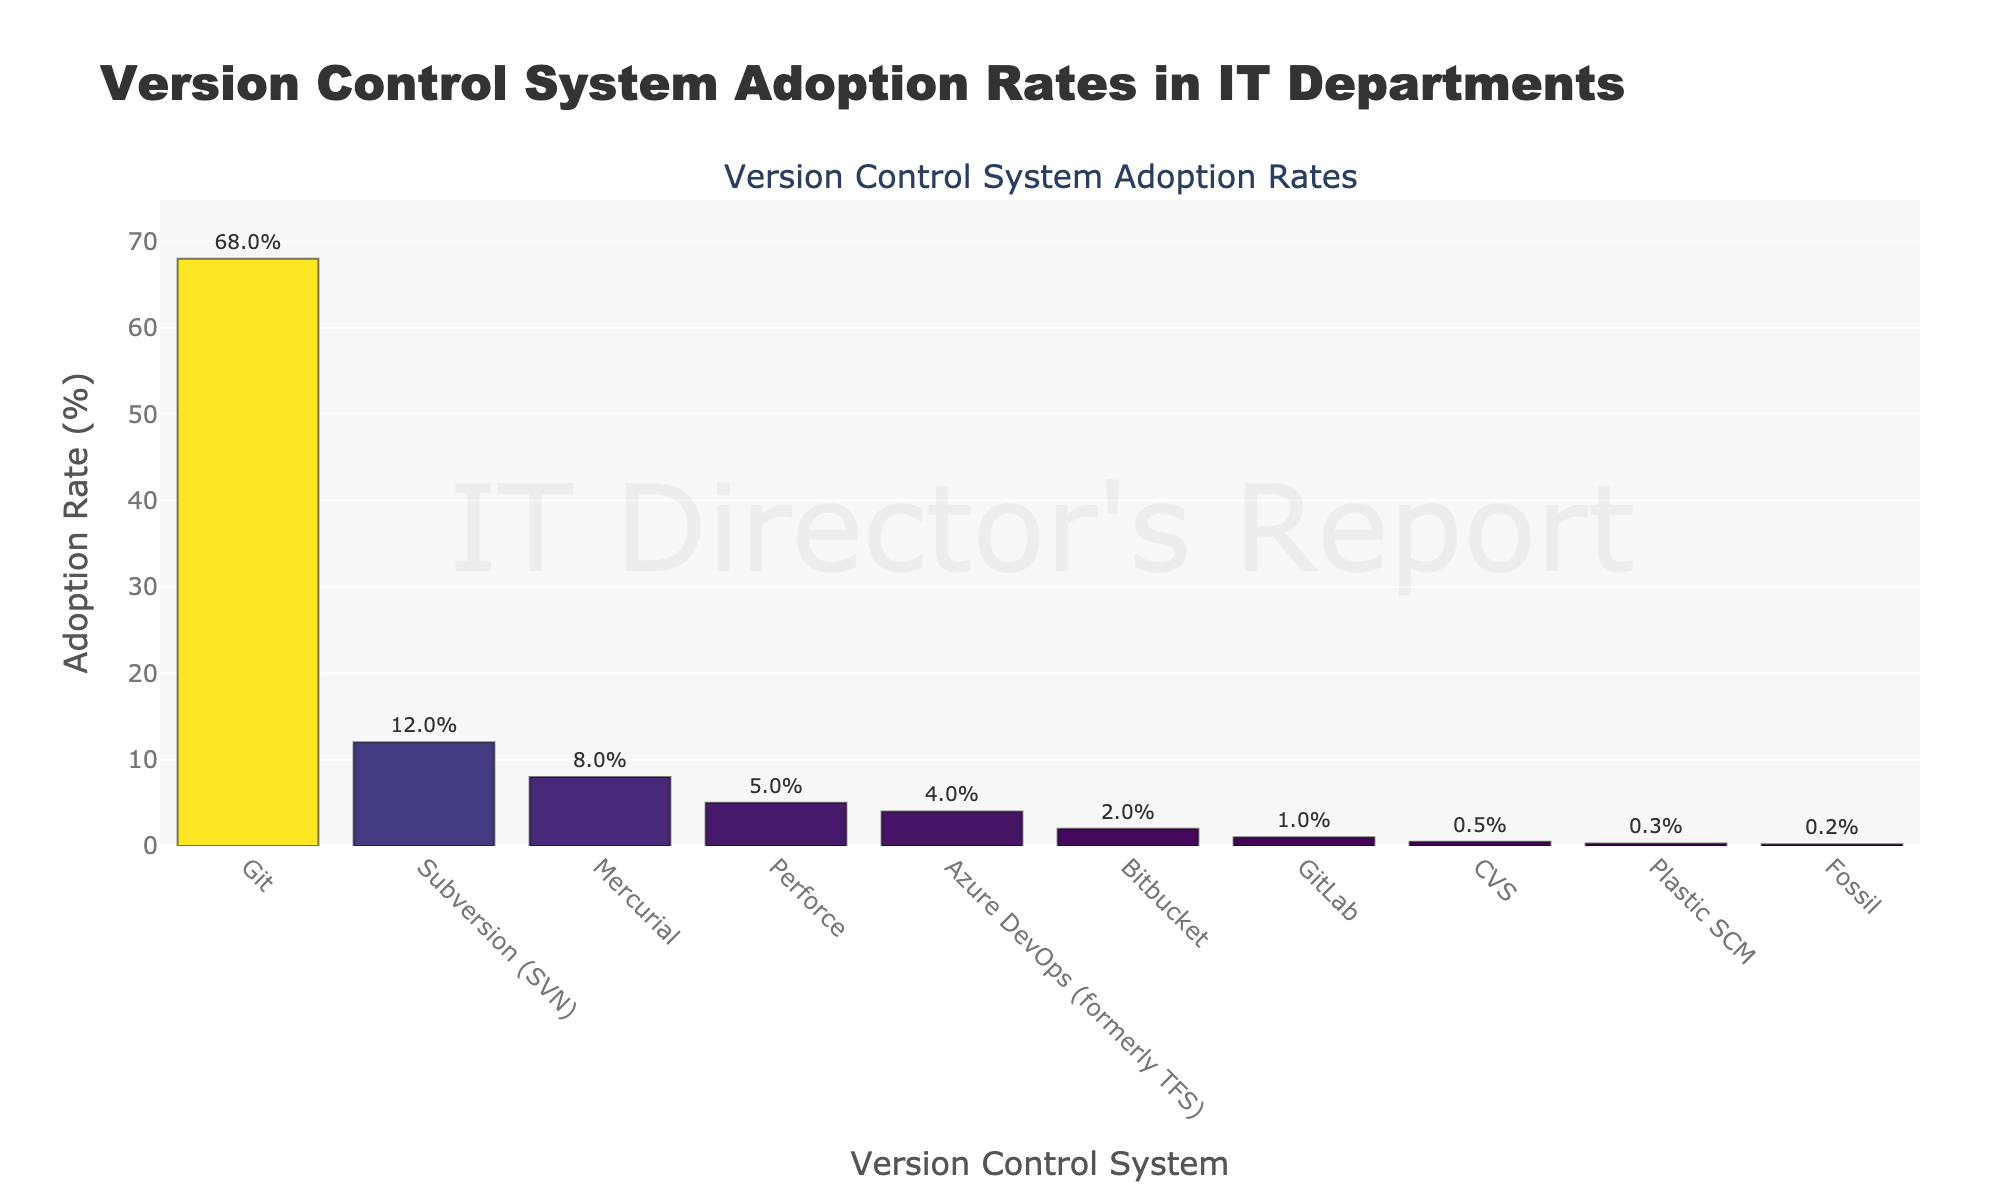What is the adoption rate of Git? Locate the bar labeled "Git" and read the value associated with it; the text on top of the Git bar shows "68%".
Answer: 68% Which version control system has the lowest adoption rate? Identify the bar with the smallest height and look at its label and value; "Fossil" has the lowest adoption rate of 0.2%.
Answer: Fossil How much higher is the adoption rate of Git compared to Subversion (SVN)? Locate the bars labeled "Git" and "Subversion (SVN)" and subtract Subversion's value from Git's value, i.e., 68% - 12%.
Answer: 56% Are there any version control systems with an adoption rate between 10% and 15%? Examine the bars to find those with values in the specified range; "Subversion (SVN)" has an adoption rate of 12%.
Answer: Subversion (SVN) What are the combined adoption rates of Mercurial, Perforce, and Azure DevOps? Find the bars for "Mercurial", "Perforce", and "Azure DevOps" and sum their values: 8% + 5% + 4% = 17%.
Answer: 17% Which version control systems have adoption rates lower than 1%? Identify bars with values below 1% and note their labels: "GitLab", "CVS", "Plastic SCM", and "Fossil".
Answer: GitLab, CVS, Plastic SCM, Fossil What is the second-most adopted version control system? Find the bar with the second highest value, which is "Subversion (SVN)" at 12%.
Answer: Subversion (SVN) How much higher is the adoption rate of Git compared to the combined adoption rate of Bitbucket and GitLab? Sum the adoption rates of Bitbucket and GitLab (2% + 1% = 3%) and subtract from Git's adoption rate (68% - 3% = 65%).
Answer: 65% Which version control system has an adoption rate closest to 5%? Locate the bar closest to 5%, which is "Perforce" with exactly 5%.
Answer: Perforce What is the difference in adoption rates between Bitbucket and Mercurial? Subtract Bitbucket's value from Mercurial's value: 8% - 2% = 6%.
Answer: 6% 